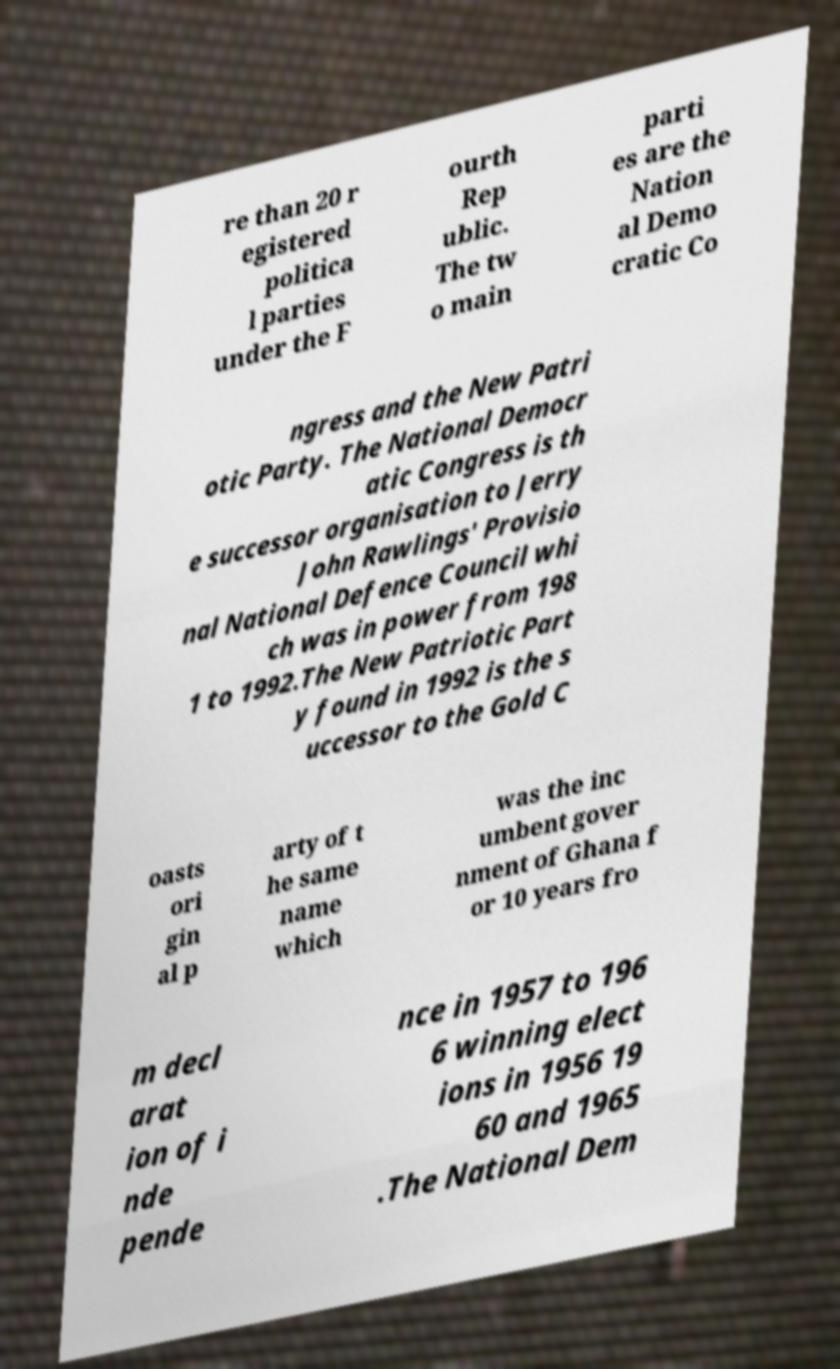Can you accurately transcribe the text from the provided image for me? re than 20 r egistered politica l parties under the F ourth Rep ublic. The tw o main parti es are the Nation al Demo cratic Co ngress and the New Patri otic Party. The National Democr atic Congress is th e successor organisation to Jerry John Rawlings' Provisio nal National Defence Council whi ch was in power from 198 1 to 1992.The New Patriotic Part y found in 1992 is the s uccessor to the Gold C oasts ori gin al p arty of t he same name which was the inc umbent gover nment of Ghana f or 10 years fro m decl arat ion of i nde pende nce in 1957 to 196 6 winning elect ions in 1956 19 60 and 1965 .The National Dem 